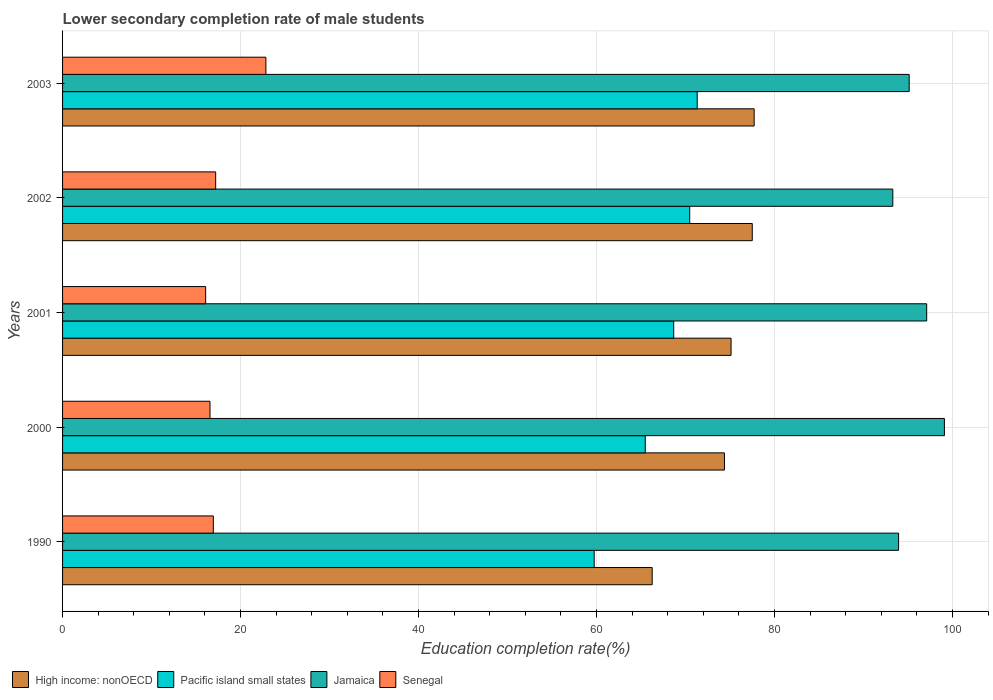How many groups of bars are there?
Your answer should be compact. 5. Are the number of bars per tick equal to the number of legend labels?
Your answer should be very brief. Yes. How many bars are there on the 2nd tick from the bottom?
Your answer should be very brief. 4. What is the label of the 2nd group of bars from the top?
Offer a very short reply. 2002. In how many cases, is the number of bars for a given year not equal to the number of legend labels?
Your answer should be very brief. 0. What is the lower secondary completion rate of male students in High income: nonOECD in 2002?
Keep it short and to the point. 77.5. Across all years, what is the maximum lower secondary completion rate of male students in Pacific island small states?
Give a very brief answer. 71.31. Across all years, what is the minimum lower secondary completion rate of male students in High income: nonOECD?
Provide a succinct answer. 66.25. In which year was the lower secondary completion rate of male students in Senegal maximum?
Offer a terse response. 2003. What is the total lower secondary completion rate of male students in Jamaica in the graph?
Provide a short and direct response. 478.56. What is the difference between the lower secondary completion rate of male students in Senegal in 2000 and that in 2001?
Your response must be concise. 0.49. What is the difference between the lower secondary completion rate of male students in High income: nonOECD in 1990 and the lower secondary completion rate of male students in Jamaica in 2003?
Your answer should be compact. -28.88. What is the average lower secondary completion rate of male students in Jamaica per year?
Offer a very short reply. 95.71. In the year 2000, what is the difference between the lower secondary completion rate of male students in Pacific island small states and lower secondary completion rate of male students in High income: nonOECD?
Your answer should be very brief. -8.9. In how many years, is the lower secondary completion rate of male students in High income: nonOECD greater than 36 %?
Your answer should be very brief. 5. What is the ratio of the lower secondary completion rate of male students in High income: nonOECD in 1990 to that in 2002?
Make the answer very short. 0.85. What is the difference between the highest and the second highest lower secondary completion rate of male students in High income: nonOECD?
Provide a short and direct response. 0.21. What is the difference between the highest and the lowest lower secondary completion rate of male students in Senegal?
Your answer should be very brief. 6.77. What does the 2nd bar from the top in 1990 represents?
Make the answer very short. Jamaica. What does the 3rd bar from the bottom in 1990 represents?
Provide a short and direct response. Jamaica. Are all the bars in the graph horizontal?
Your response must be concise. Yes. Are the values on the major ticks of X-axis written in scientific E-notation?
Offer a very short reply. No. Does the graph contain any zero values?
Your response must be concise. No. Where does the legend appear in the graph?
Ensure brevity in your answer.  Bottom left. What is the title of the graph?
Provide a short and direct response. Lower secondary completion rate of male students. Does "Barbados" appear as one of the legend labels in the graph?
Your answer should be compact. No. What is the label or title of the X-axis?
Offer a terse response. Education completion rate(%). What is the Education completion rate(%) in High income: nonOECD in 1990?
Make the answer very short. 66.25. What is the Education completion rate(%) of Pacific island small states in 1990?
Offer a terse response. 59.74. What is the Education completion rate(%) of Jamaica in 1990?
Keep it short and to the point. 93.94. What is the Education completion rate(%) in Senegal in 1990?
Provide a succinct answer. 16.94. What is the Education completion rate(%) of High income: nonOECD in 2000?
Provide a short and direct response. 74.37. What is the Education completion rate(%) of Pacific island small states in 2000?
Keep it short and to the point. 65.48. What is the Education completion rate(%) of Jamaica in 2000?
Your response must be concise. 99.09. What is the Education completion rate(%) of Senegal in 2000?
Your answer should be compact. 16.57. What is the Education completion rate(%) of High income: nonOECD in 2001?
Ensure brevity in your answer.  75.12. What is the Education completion rate(%) of Pacific island small states in 2001?
Your answer should be compact. 68.67. What is the Education completion rate(%) of Jamaica in 2001?
Provide a short and direct response. 97.1. What is the Education completion rate(%) of Senegal in 2001?
Offer a very short reply. 16.08. What is the Education completion rate(%) in High income: nonOECD in 2002?
Make the answer very short. 77.5. What is the Education completion rate(%) of Pacific island small states in 2002?
Give a very brief answer. 70.47. What is the Education completion rate(%) of Jamaica in 2002?
Offer a terse response. 93.29. What is the Education completion rate(%) in Senegal in 2002?
Ensure brevity in your answer.  17.2. What is the Education completion rate(%) in High income: nonOECD in 2003?
Your response must be concise. 77.71. What is the Education completion rate(%) of Pacific island small states in 2003?
Keep it short and to the point. 71.31. What is the Education completion rate(%) of Jamaica in 2003?
Keep it short and to the point. 95.13. What is the Education completion rate(%) in Senegal in 2003?
Your response must be concise. 22.85. Across all years, what is the maximum Education completion rate(%) of High income: nonOECD?
Provide a succinct answer. 77.71. Across all years, what is the maximum Education completion rate(%) in Pacific island small states?
Your answer should be very brief. 71.31. Across all years, what is the maximum Education completion rate(%) of Jamaica?
Keep it short and to the point. 99.09. Across all years, what is the maximum Education completion rate(%) of Senegal?
Provide a short and direct response. 22.85. Across all years, what is the minimum Education completion rate(%) of High income: nonOECD?
Your answer should be compact. 66.25. Across all years, what is the minimum Education completion rate(%) in Pacific island small states?
Your answer should be compact. 59.74. Across all years, what is the minimum Education completion rate(%) in Jamaica?
Your answer should be compact. 93.29. Across all years, what is the minimum Education completion rate(%) of Senegal?
Keep it short and to the point. 16.08. What is the total Education completion rate(%) of High income: nonOECD in the graph?
Your response must be concise. 370.96. What is the total Education completion rate(%) of Pacific island small states in the graph?
Your answer should be very brief. 335.67. What is the total Education completion rate(%) of Jamaica in the graph?
Offer a very short reply. 478.56. What is the total Education completion rate(%) of Senegal in the graph?
Provide a succinct answer. 89.64. What is the difference between the Education completion rate(%) in High income: nonOECD in 1990 and that in 2000?
Offer a terse response. -8.12. What is the difference between the Education completion rate(%) of Pacific island small states in 1990 and that in 2000?
Ensure brevity in your answer.  -5.74. What is the difference between the Education completion rate(%) in Jamaica in 1990 and that in 2000?
Ensure brevity in your answer.  -5.15. What is the difference between the Education completion rate(%) of Senegal in 1990 and that in 2000?
Offer a very short reply. 0.37. What is the difference between the Education completion rate(%) in High income: nonOECD in 1990 and that in 2001?
Make the answer very short. -8.86. What is the difference between the Education completion rate(%) of Pacific island small states in 1990 and that in 2001?
Your answer should be compact. -8.94. What is the difference between the Education completion rate(%) in Jamaica in 1990 and that in 2001?
Provide a short and direct response. -3.16. What is the difference between the Education completion rate(%) in Senegal in 1990 and that in 2001?
Give a very brief answer. 0.86. What is the difference between the Education completion rate(%) in High income: nonOECD in 1990 and that in 2002?
Offer a terse response. -11.25. What is the difference between the Education completion rate(%) in Pacific island small states in 1990 and that in 2002?
Give a very brief answer. -10.73. What is the difference between the Education completion rate(%) in Jamaica in 1990 and that in 2002?
Provide a short and direct response. 0.65. What is the difference between the Education completion rate(%) in Senegal in 1990 and that in 2002?
Provide a short and direct response. -0.26. What is the difference between the Education completion rate(%) of High income: nonOECD in 1990 and that in 2003?
Offer a very short reply. -11.46. What is the difference between the Education completion rate(%) of Pacific island small states in 1990 and that in 2003?
Ensure brevity in your answer.  -11.57. What is the difference between the Education completion rate(%) in Jamaica in 1990 and that in 2003?
Your answer should be very brief. -1.19. What is the difference between the Education completion rate(%) of Senegal in 1990 and that in 2003?
Keep it short and to the point. -5.91. What is the difference between the Education completion rate(%) of High income: nonOECD in 2000 and that in 2001?
Offer a terse response. -0.74. What is the difference between the Education completion rate(%) in Pacific island small states in 2000 and that in 2001?
Your answer should be very brief. -3.2. What is the difference between the Education completion rate(%) of Jamaica in 2000 and that in 2001?
Provide a short and direct response. 1.99. What is the difference between the Education completion rate(%) in Senegal in 2000 and that in 2001?
Provide a succinct answer. 0.49. What is the difference between the Education completion rate(%) of High income: nonOECD in 2000 and that in 2002?
Give a very brief answer. -3.13. What is the difference between the Education completion rate(%) of Pacific island small states in 2000 and that in 2002?
Offer a very short reply. -4.99. What is the difference between the Education completion rate(%) of Jamaica in 2000 and that in 2002?
Offer a terse response. 5.8. What is the difference between the Education completion rate(%) in Senegal in 2000 and that in 2002?
Ensure brevity in your answer.  -0.64. What is the difference between the Education completion rate(%) of High income: nonOECD in 2000 and that in 2003?
Ensure brevity in your answer.  -3.34. What is the difference between the Education completion rate(%) of Pacific island small states in 2000 and that in 2003?
Offer a very short reply. -5.84. What is the difference between the Education completion rate(%) in Jamaica in 2000 and that in 2003?
Offer a terse response. 3.96. What is the difference between the Education completion rate(%) in Senegal in 2000 and that in 2003?
Ensure brevity in your answer.  -6.28. What is the difference between the Education completion rate(%) in High income: nonOECD in 2001 and that in 2002?
Give a very brief answer. -2.38. What is the difference between the Education completion rate(%) in Pacific island small states in 2001 and that in 2002?
Provide a succinct answer. -1.8. What is the difference between the Education completion rate(%) in Jamaica in 2001 and that in 2002?
Your answer should be very brief. 3.81. What is the difference between the Education completion rate(%) of Senegal in 2001 and that in 2002?
Your response must be concise. -1.12. What is the difference between the Education completion rate(%) in High income: nonOECD in 2001 and that in 2003?
Give a very brief answer. -2.59. What is the difference between the Education completion rate(%) of Pacific island small states in 2001 and that in 2003?
Provide a succinct answer. -2.64. What is the difference between the Education completion rate(%) of Jamaica in 2001 and that in 2003?
Offer a terse response. 1.97. What is the difference between the Education completion rate(%) of Senegal in 2001 and that in 2003?
Ensure brevity in your answer.  -6.77. What is the difference between the Education completion rate(%) of High income: nonOECD in 2002 and that in 2003?
Offer a terse response. -0.21. What is the difference between the Education completion rate(%) of Pacific island small states in 2002 and that in 2003?
Provide a short and direct response. -0.84. What is the difference between the Education completion rate(%) of Jamaica in 2002 and that in 2003?
Keep it short and to the point. -1.84. What is the difference between the Education completion rate(%) of Senegal in 2002 and that in 2003?
Offer a very short reply. -5.64. What is the difference between the Education completion rate(%) in High income: nonOECD in 1990 and the Education completion rate(%) in Pacific island small states in 2000?
Offer a terse response. 0.78. What is the difference between the Education completion rate(%) of High income: nonOECD in 1990 and the Education completion rate(%) of Jamaica in 2000?
Your answer should be compact. -32.84. What is the difference between the Education completion rate(%) in High income: nonOECD in 1990 and the Education completion rate(%) in Senegal in 2000?
Offer a very short reply. 49.69. What is the difference between the Education completion rate(%) in Pacific island small states in 1990 and the Education completion rate(%) in Jamaica in 2000?
Make the answer very short. -39.35. What is the difference between the Education completion rate(%) in Pacific island small states in 1990 and the Education completion rate(%) in Senegal in 2000?
Give a very brief answer. 43.17. What is the difference between the Education completion rate(%) in Jamaica in 1990 and the Education completion rate(%) in Senegal in 2000?
Ensure brevity in your answer.  77.38. What is the difference between the Education completion rate(%) of High income: nonOECD in 1990 and the Education completion rate(%) of Pacific island small states in 2001?
Your response must be concise. -2.42. What is the difference between the Education completion rate(%) of High income: nonOECD in 1990 and the Education completion rate(%) of Jamaica in 2001?
Provide a succinct answer. -30.85. What is the difference between the Education completion rate(%) in High income: nonOECD in 1990 and the Education completion rate(%) in Senegal in 2001?
Your response must be concise. 50.18. What is the difference between the Education completion rate(%) of Pacific island small states in 1990 and the Education completion rate(%) of Jamaica in 2001?
Make the answer very short. -37.36. What is the difference between the Education completion rate(%) in Pacific island small states in 1990 and the Education completion rate(%) in Senegal in 2001?
Provide a short and direct response. 43.66. What is the difference between the Education completion rate(%) of Jamaica in 1990 and the Education completion rate(%) of Senegal in 2001?
Your answer should be compact. 77.86. What is the difference between the Education completion rate(%) of High income: nonOECD in 1990 and the Education completion rate(%) of Pacific island small states in 2002?
Offer a very short reply. -4.22. What is the difference between the Education completion rate(%) of High income: nonOECD in 1990 and the Education completion rate(%) of Jamaica in 2002?
Make the answer very short. -27.04. What is the difference between the Education completion rate(%) in High income: nonOECD in 1990 and the Education completion rate(%) in Senegal in 2002?
Your answer should be compact. 49.05. What is the difference between the Education completion rate(%) of Pacific island small states in 1990 and the Education completion rate(%) of Jamaica in 2002?
Make the answer very short. -33.56. What is the difference between the Education completion rate(%) in Pacific island small states in 1990 and the Education completion rate(%) in Senegal in 2002?
Offer a terse response. 42.53. What is the difference between the Education completion rate(%) in Jamaica in 1990 and the Education completion rate(%) in Senegal in 2002?
Provide a succinct answer. 76.74. What is the difference between the Education completion rate(%) in High income: nonOECD in 1990 and the Education completion rate(%) in Pacific island small states in 2003?
Ensure brevity in your answer.  -5.06. What is the difference between the Education completion rate(%) in High income: nonOECD in 1990 and the Education completion rate(%) in Jamaica in 2003?
Give a very brief answer. -28.88. What is the difference between the Education completion rate(%) of High income: nonOECD in 1990 and the Education completion rate(%) of Senegal in 2003?
Offer a terse response. 43.41. What is the difference between the Education completion rate(%) in Pacific island small states in 1990 and the Education completion rate(%) in Jamaica in 2003?
Keep it short and to the point. -35.39. What is the difference between the Education completion rate(%) in Pacific island small states in 1990 and the Education completion rate(%) in Senegal in 2003?
Give a very brief answer. 36.89. What is the difference between the Education completion rate(%) in Jamaica in 1990 and the Education completion rate(%) in Senegal in 2003?
Give a very brief answer. 71.1. What is the difference between the Education completion rate(%) of High income: nonOECD in 2000 and the Education completion rate(%) of Pacific island small states in 2001?
Offer a very short reply. 5.7. What is the difference between the Education completion rate(%) of High income: nonOECD in 2000 and the Education completion rate(%) of Jamaica in 2001?
Ensure brevity in your answer.  -22.73. What is the difference between the Education completion rate(%) of High income: nonOECD in 2000 and the Education completion rate(%) of Senegal in 2001?
Provide a succinct answer. 58.3. What is the difference between the Education completion rate(%) of Pacific island small states in 2000 and the Education completion rate(%) of Jamaica in 2001?
Your answer should be compact. -31.62. What is the difference between the Education completion rate(%) of Pacific island small states in 2000 and the Education completion rate(%) of Senegal in 2001?
Offer a very short reply. 49.4. What is the difference between the Education completion rate(%) of Jamaica in 2000 and the Education completion rate(%) of Senegal in 2001?
Provide a succinct answer. 83.01. What is the difference between the Education completion rate(%) in High income: nonOECD in 2000 and the Education completion rate(%) in Pacific island small states in 2002?
Keep it short and to the point. 3.9. What is the difference between the Education completion rate(%) of High income: nonOECD in 2000 and the Education completion rate(%) of Jamaica in 2002?
Provide a short and direct response. -18.92. What is the difference between the Education completion rate(%) in High income: nonOECD in 2000 and the Education completion rate(%) in Senegal in 2002?
Your answer should be compact. 57.17. What is the difference between the Education completion rate(%) in Pacific island small states in 2000 and the Education completion rate(%) in Jamaica in 2002?
Offer a terse response. -27.82. What is the difference between the Education completion rate(%) in Pacific island small states in 2000 and the Education completion rate(%) in Senegal in 2002?
Keep it short and to the point. 48.27. What is the difference between the Education completion rate(%) in Jamaica in 2000 and the Education completion rate(%) in Senegal in 2002?
Your response must be concise. 81.89. What is the difference between the Education completion rate(%) of High income: nonOECD in 2000 and the Education completion rate(%) of Pacific island small states in 2003?
Provide a short and direct response. 3.06. What is the difference between the Education completion rate(%) in High income: nonOECD in 2000 and the Education completion rate(%) in Jamaica in 2003?
Provide a succinct answer. -20.76. What is the difference between the Education completion rate(%) of High income: nonOECD in 2000 and the Education completion rate(%) of Senegal in 2003?
Give a very brief answer. 51.53. What is the difference between the Education completion rate(%) in Pacific island small states in 2000 and the Education completion rate(%) in Jamaica in 2003?
Your answer should be compact. -29.66. What is the difference between the Education completion rate(%) of Pacific island small states in 2000 and the Education completion rate(%) of Senegal in 2003?
Provide a short and direct response. 42.63. What is the difference between the Education completion rate(%) of Jamaica in 2000 and the Education completion rate(%) of Senegal in 2003?
Offer a very short reply. 76.24. What is the difference between the Education completion rate(%) of High income: nonOECD in 2001 and the Education completion rate(%) of Pacific island small states in 2002?
Your response must be concise. 4.65. What is the difference between the Education completion rate(%) in High income: nonOECD in 2001 and the Education completion rate(%) in Jamaica in 2002?
Offer a very short reply. -18.18. What is the difference between the Education completion rate(%) of High income: nonOECD in 2001 and the Education completion rate(%) of Senegal in 2002?
Make the answer very short. 57.91. What is the difference between the Education completion rate(%) of Pacific island small states in 2001 and the Education completion rate(%) of Jamaica in 2002?
Offer a terse response. -24.62. What is the difference between the Education completion rate(%) of Pacific island small states in 2001 and the Education completion rate(%) of Senegal in 2002?
Your response must be concise. 51.47. What is the difference between the Education completion rate(%) of Jamaica in 2001 and the Education completion rate(%) of Senegal in 2002?
Offer a very short reply. 79.9. What is the difference between the Education completion rate(%) of High income: nonOECD in 2001 and the Education completion rate(%) of Pacific island small states in 2003?
Give a very brief answer. 3.8. What is the difference between the Education completion rate(%) of High income: nonOECD in 2001 and the Education completion rate(%) of Jamaica in 2003?
Offer a very short reply. -20.02. What is the difference between the Education completion rate(%) in High income: nonOECD in 2001 and the Education completion rate(%) in Senegal in 2003?
Provide a short and direct response. 52.27. What is the difference between the Education completion rate(%) of Pacific island small states in 2001 and the Education completion rate(%) of Jamaica in 2003?
Make the answer very short. -26.46. What is the difference between the Education completion rate(%) in Pacific island small states in 2001 and the Education completion rate(%) in Senegal in 2003?
Give a very brief answer. 45.83. What is the difference between the Education completion rate(%) of Jamaica in 2001 and the Education completion rate(%) of Senegal in 2003?
Make the answer very short. 74.25. What is the difference between the Education completion rate(%) of High income: nonOECD in 2002 and the Education completion rate(%) of Pacific island small states in 2003?
Offer a very short reply. 6.19. What is the difference between the Education completion rate(%) of High income: nonOECD in 2002 and the Education completion rate(%) of Jamaica in 2003?
Your answer should be very brief. -17.63. What is the difference between the Education completion rate(%) in High income: nonOECD in 2002 and the Education completion rate(%) in Senegal in 2003?
Ensure brevity in your answer.  54.65. What is the difference between the Education completion rate(%) of Pacific island small states in 2002 and the Education completion rate(%) of Jamaica in 2003?
Give a very brief answer. -24.66. What is the difference between the Education completion rate(%) in Pacific island small states in 2002 and the Education completion rate(%) in Senegal in 2003?
Provide a short and direct response. 47.62. What is the difference between the Education completion rate(%) of Jamaica in 2002 and the Education completion rate(%) of Senegal in 2003?
Make the answer very short. 70.45. What is the average Education completion rate(%) of High income: nonOECD per year?
Make the answer very short. 74.19. What is the average Education completion rate(%) of Pacific island small states per year?
Offer a terse response. 67.13. What is the average Education completion rate(%) of Jamaica per year?
Make the answer very short. 95.71. What is the average Education completion rate(%) of Senegal per year?
Ensure brevity in your answer.  17.93. In the year 1990, what is the difference between the Education completion rate(%) of High income: nonOECD and Education completion rate(%) of Pacific island small states?
Provide a short and direct response. 6.52. In the year 1990, what is the difference between the Education completion rate(%) in High income: nonOECD and Education completion rate(%) in Jamaica?
Offer a terse response. -27.69. In the year 1990, what is the difference between the Education completion rate(%) of High income: nonOECD and Education completion rate(%) of Senegal?
Your answer should be compact. 49.32. In the year 1990, what is the difference between the Education completion rate(%) in Pacific island small states and Education completion rate(%) in Jamaica?
Offer a terse response. -34.21. In the year 1990, what is the difference between the Education completion rate(%) of Pacific island small states and Education completion rate(%) of Senegal?
Your answer should be very brief. 42.8. In the year 1990, what is the difference between the Education completion rate(%) in Jamaica and Education completion rate(%) in Senegal?
Your response must be concise. 77. In the year 2000, what is the difference between the Education completion rate(%) of High income: nonOECD and Education completion rate(%) of Pacific island small states?
Keep it short and to the point. 8.9. In the year 2000, what is the difference between the Education completion rate(%) of High income: nonOECD and Education completion rate(%) of Jamaica?
Ensure brevity in your answer.  -24.72. In the year 2000, what is the difference between the Education completion rate(%) of High income: nonOECD and Education completion rate(%) of Senegal?
Offer a very short reply. 57.81. In the year 2000, what is the difference between the Education completion rate(%) of Pacific island small states and Education completion rate(%) of Jamaica?
Keep it short and to the point. -33.61. In the year 2000, what is the difference between the Education completion rate(%) in Pacific island small states and Education completion rate(%) in Senegal?
Give a very brief answer. 48.91. In the year 2000, what is the difference between the Education completion rate(%) in Jamaica and Education completion rate(%) in Senegal?
Give a very brief answer. 82.52. In the year 2001, what is the difference between the Education completion rate(%) in High income: nonOECD and Education completion rate(%) in Pacific island small states?
Ensure brevity in your answer.  6.44. In the year 2001, what is the difference between the Education completion rate(%) of High income: nonOECD and Education completion rate(%) of Jamaica?
Your response must be concise. -21.98. In the year 2001, what is the difference between the Education completion rate(%) in High income: nonOECD and Education completion rate(%) in Senegal?
Provide a succinct answer. 59.04. In the year 2001, what is the difference between the Education completion rate(%) in Pacific island small states and Education completion rate(%) in Jamaica?
Your answer should be compact. -28.43. In the year 2001, what is the difference between the Education completion rate(%) of Pacific island small states and Education completion rate(%) of Senegal?
Make the answer very short. 52.59. In the year 2001, what is the difference between the Education completion rate(%) in Jamaica and Education completion rate(%) in Senegal?
Offer a terse response. 81.02. In the year 2002, what is the difference between the Education completion rate(%) in High income: nonOECD and Education completion rate(%) in Pacific island small states?
Ensure brevity in your answer.  7.03. In the year 2002, what is the difference between the Education completion rate(%) in High income: nonOECD and Education completion rate(%) in Jamaica?
Your response must be concise. -15.79. In the year 2002, what is the difference between the Education completion rate(%) in High income: nonOECD and Education completion rate(%) in Senegal?
Your answer should be very brief. 60.3. In the year 2002, what is the difference between the Education completion rate(%) of Pacific island small states and Education completion rate(%) of Jamaica?
Give a very brief answer. -22.82. In the year 2002, what is the difference between the Education completion rate(%) of Pacific island small states and Education completion rate(%) of Senegal?
Keep it short and to the point. 53.27. In the year 2002, what is the difference between the Education completion rate(%) of Jamaica and Education completion rate(%) of Senegal?
Your response must be concise. 76.09. In the year 2003, what is the difference between the Education completion rate(%) in High income: nonOECD and Education completion rate(%) in Pacific island small states?
Give a very brief answer. 6.4. In the year 2003, what is the difference between the Education completion rate(%) in High income: nonOECD and Education completion rate(%) in Jamaica?
Make the answer very short. -17.42. In the year 2003, what is the difference between the Education completion rate(%) in High income: nonOECD and Education completion rate(%) in Senegal?
Offer a terse response. 54.86. In the year 2003, what is the difference between the Education completion rate(%) in Pacific island small states and Education completion rate(%) in Jamaica?
Your answer should be compact. -23.82. In the year 2003, what is the difference between the Education completion rate(%) of Pacific island small states and Education completion rate(%) of Senegal?
Offer a terse response. 48.47. In the year 2003, what is the difference between the Education completion rate(%) in Jamaica and Education completion rate(%) in Senegal?
Make the answer very short. 72.29. What is the ratio of the Education completion rate(%) of High income: nonOECD in 1990 to that in 2000?
Provide a succinct answer. 0.89. What is the ratio of the Education completion rate(%) in Pacific island small states in 1990 to that in 2000?
Your response must be concise. 0.91. What is the ratio of the Education completion rate(%) of Jamaica in 1990 to that in 2000?
Your answer should be very brief. 0.95. What is the ratio of the Education completion rate(%) in Senegal in 1990 to that in 2000?
Offer a terse response. 1.02. What is the ratio of the Education completion rate(%) in High income: nonOECD in 1990 to that in 2001?
Offer a terse response. 0.88. What is the ratio of the Education completion rate(%) of Pacific island small states in 1990 to that in 2001?
Provide a succinct answer. 0.87. What is the ratio of the Education completion rate(%) in Jamaica in 1990 to that in 2001?
Your answer should be compact. 0.97. What is the ratio of the Education completion rate(%) in Senegal in 1990 to that in 2001?
Your answer should be very brief. 1.05. What is the ratio of the Education completion rate(%) in High income: nonOECD in 1990 to that in 2002?
Keep it short and to the point. 0.85. What is the ratio of the Education completion rate(%) of Pacific island small states in 1990 to that in 2002?
Provide a succinct answer. 0.85. What is the ratio of the Education completion rate(%) of Jamaica in 1990 to that in 2002?
Keep it short and to the point. 1.01. What is the ratio of the Education completion rate(%) in Senegal in 1990 to that in 2002?
Keep it short and to the point. 0.98. What is the ratio of the Education completion rate(%) in High income: nonOECD in 1990 to that in 2003?
Your answer should be very brief. 0.85. What is the ratio of the Education completion rate(%) in Pacific island small states in 1990 to that in 2003?
Ensure brevity in your answer.  0.84. What is the ratio of the Education completion rate(%) in Jamaica in 1990 to that in 2003?
Offer a terse response. 0.99. What is the ratio of the Education completion rate(%) of Senegal in 1990 to that in 2003?
Offer a terse response. 0.74. What is the ratio of the Education completion rate(%) in High income: nonOECD in 2000 to that in 2001?
Ensure brevity in your answer.  0.99. What is the ratio of the Education completion rate(%) of Pacific island small states in 2000 to that in 2001?
Your response must be concise. 0.95. What is the ratio of the Education completion rate(%) of Jamaica in 2000 to that in 2001?
Make the answer very short. 1.02. What is the ratio of the Education completion rate(%) in Senegal in 2000 to that in 2001?
Your answer should be very brief. 1.03. What is the ratio of the Education completion rate(%) in High income: nonOECD in 2000 to that in 2002?
Your answer should be very brief. 0.96. What is the ratio of the Education completion rate(%) of Pacific island small states in 2000 to that in 2002?
Keep it short and to the point. 0.93. What is the ratio of the Education completion rate(%) of Jamaica in 2000 to that in 2002?
Your answer should be very brief. 1.06. What is the ratio of the Education completion rate(%) in High income: nonOECD in 2000 to that in 2003?
Your answer should be compact. 0.96. What is the ratio of the Education completion rate(%) in Pacific island small states in 2000 to that in 2003?
Give a very brief answer. 0.92. What is the ratio of the Education completion rate(%) of Jamaica in 2000 to that in 2003?
Ensure brevity in your answer.  1.04. What is the ratio of the Education completion rate(%) of Senegal in 2000 to that in 2003?
Provide a short and direct response. 0.73. What is the ratio of the Education completion rate(%) in High income: nonOECD in 2001 to that in 2002?
Keep it short and to the point. 0.97. What is the ratio of the Education completion rate(%) of Pacific island small states in 2001 to that in 2002?
Your response must be concise. 0.97. What is the ratio of the Education completion rate(%) of Jamaica in 2001 to that in 2002?
Keep it short and to the point. 1.04. What is the ratio of the Education completion rate(%) in Senegal in 2001 to that in 2002?
Your answer should be compact. 0.93. What is the ratio of the Education completion rate(%) in High income: nonOECD in 2001 to that in 2003?
Ensure brevity in your answer.  0.97. What is the ratio of the Education completion rate(%) of Jamaica in 2001 to that in 2003?
Your answer should be very brief. 1.02. What is the ratio of the Education completion rate(%) in Senegal in 2001 to that in 2003?
Your answer should be compact. 0.7. What is the ratio of the Education completion rate(%) of Jamaica in 2002 to that in 2003?
Give a very brief answer. 0.98. What is the ratio of the Education completion rate(%) in Senegal in 2002 to that in 2003?
Ensure brevity in your answer.  0.75. What is the difference between the highest and the second highest Education completion rate(%) of High income: nonOECD?
Give a very brief answer. 0.21. What is the difference between the highest and the second highest Education completion rate(%) in Pacific island small states?
Make the answer very short. 0.84. What is the difference between the highest and the second highest Education completion rate(%) of Jamaica?
Offer a terse response. 1.99. What is the difference between the highest and the second highest Education completion rate(%) of Senegal?
Your answer should be very brief. 5.64. What is the difference between the highest and the lowest Education completion rate(%) of High income: nonOECD?
Give a very brief answer. 11.46. What is the difference between the highest and the lowest Education completion rate(%) of Pacific island small states?
Provide a succinct answer. 11.57. What is the difference between the highest and the lowest Education completion rate(%) in Jamaica?
Provide a succinct answer. 5.8. What is the difference between the highest and the lowest Education completion rate(%) in Senegal?
Your answer should be very brief. 6.77. 